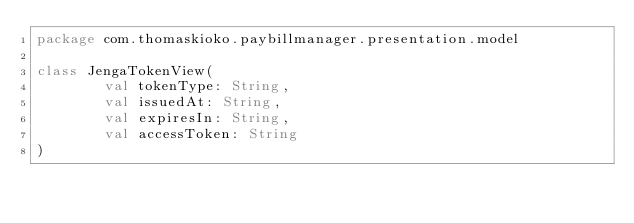Convert code to text. <code><loc_0><loc_0><loc_500><loc_500><_Kotlin_>package com.thomaskioko.paybillmanager.presentation.model

class JengaTokenView(
        val tokenType: String,
        val issuedAt: String,
        val expiresIn: String,
        val accessToken: String
)</code> 